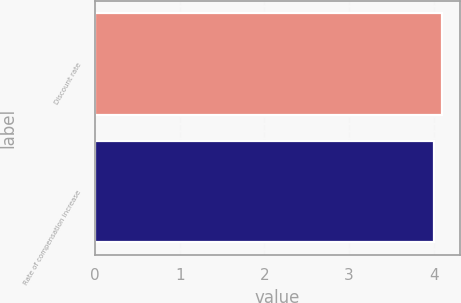Convert chart. <chart><loc_0><loc_0><loc_500><loc_500><bar_chart><fcel>Discount rate<fcel>Rate of compensation increase<nl><fcel>4.1<fcel>4<nl></chart> 